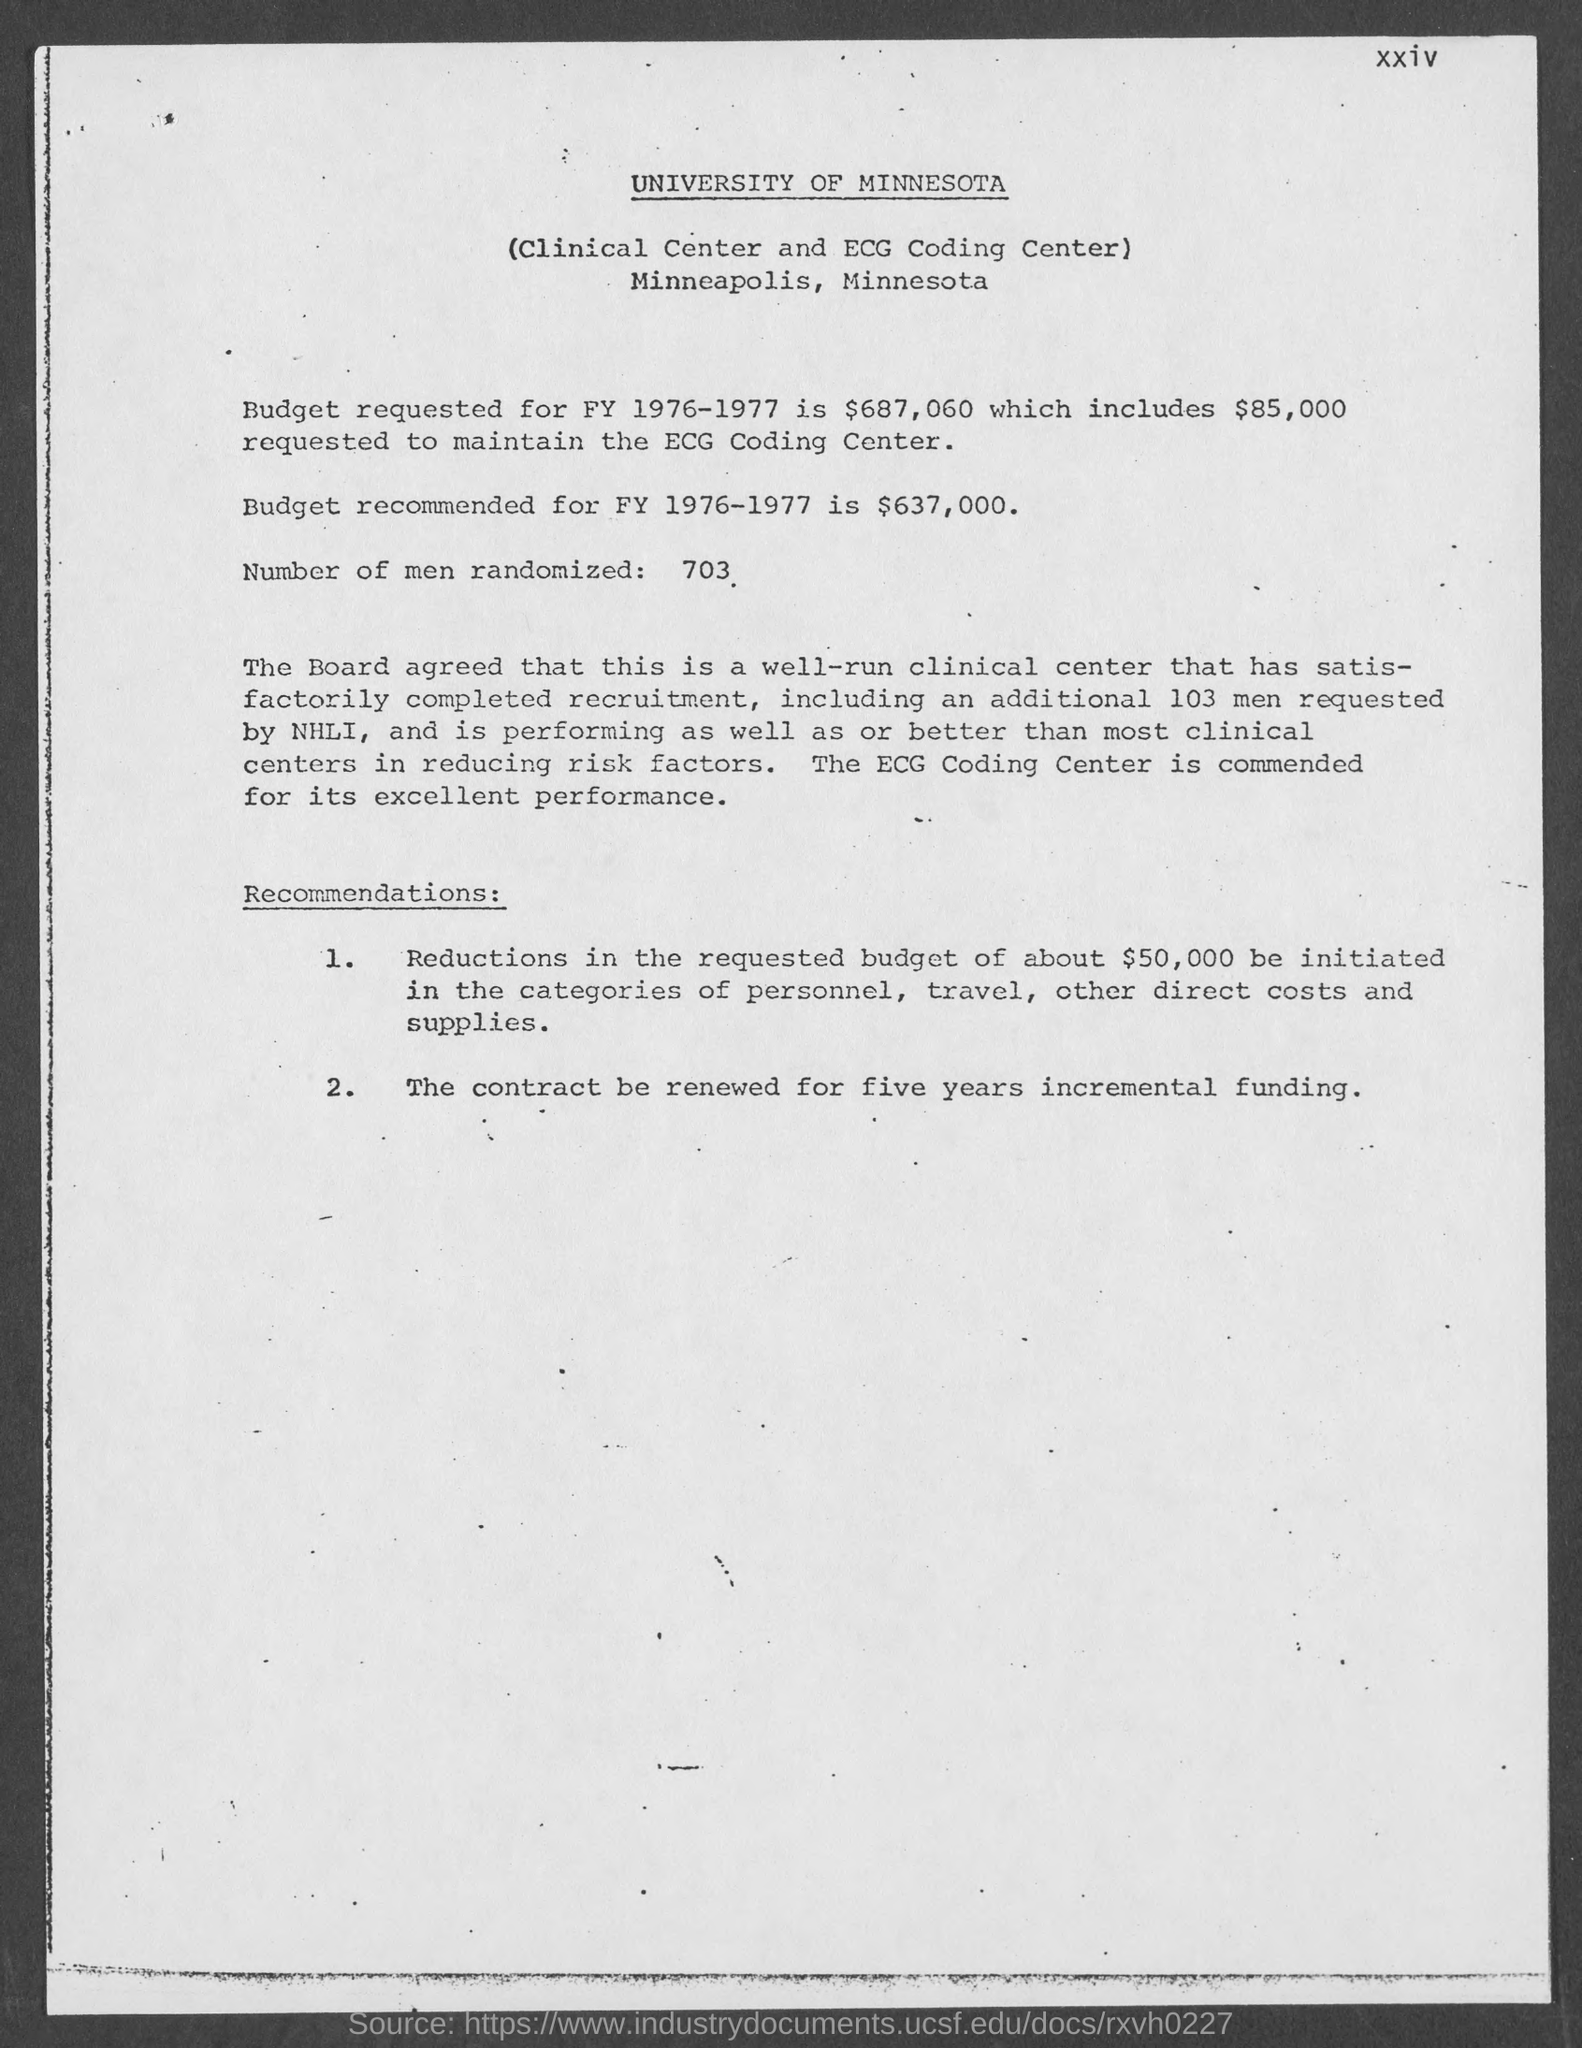What is the number of men randomized given in the document?
Your answer should be compact. 703. Which university is mentioned in the header of the document?
Give a very brief answer. University of Minnesota. 